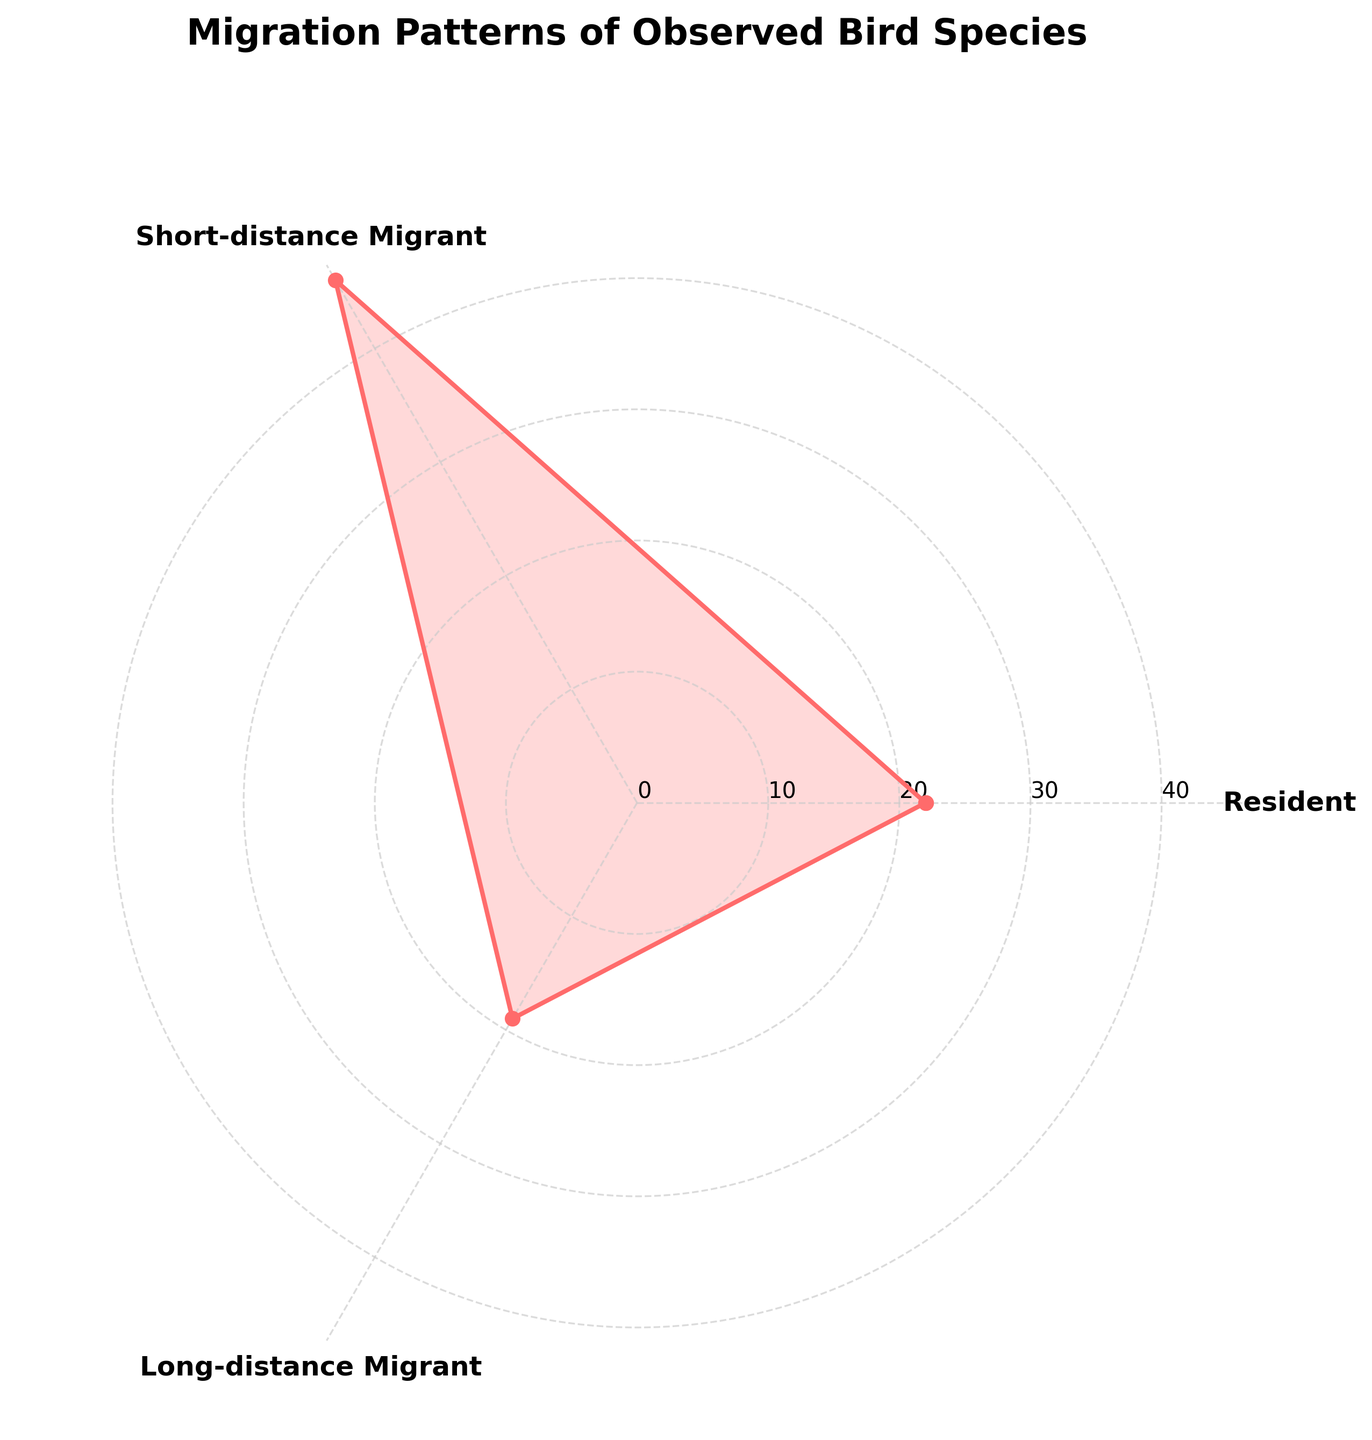What is the title of the rose chart? The title of the chart is typically displayed at the top of the plot. It provides a brief description of the dataset being visualized.
Answer: Migration Patterns of Observed Bird Species How many groups are represented in the rose chart? The rose chart categorizes the migration patterns into different groups. These groups are usually marked by labels around the chart.
Answer: 3 groups Which category has the highest value? To find the category with the highest value, look at the lengths of the segments extending from the center to the outer edge. The segment that extends the farthest represents the highest value.
Answer: Short-distance Migrant What is the approximate value for the Long-distance Migrant category? Look at the segment labeled "Long-distance Migrant" and estimate its value by comparing it to the radial labels.
Answer: Approximately 19 Compare the values for Resident and Short-distance Migrant categories. Which one is higher? To compare, visually check the lengths of the segments for both categories. The longer segment indicates a higher value.
Answer: Short-distance Migrant Is there any category with a value of 0? Check each segment for any category that does not extend from the center. If one category has no segment, it means its value is zero.
Answer: No What is the total value of all categories combined? Add the values of all the segments for the categories displayed on the rose chart. Sum up Resident (22), Short-distance Migrant (46), and Long-distance Migrant (19).
Answer: 87 Which group is closest in value to the Long-distance Migrant? Visually inspect the values of each category, and find the one closest in length to the Long-distance Migrant segment.
Answer: Resident How does the Resident category compare to the average value of all categories? First, calculate the average value of all categories ([22 + 46 + 19]/3 = 29). Then compare the value of the Resident category to this average.
Answer: Lower What is the difference between the highest and the lowest category values? Identify the highest and lowest values among the segments and subtract the lowest from the highest. The highest (Short-distance Migrant: 46) minus the lowest (Long-distance Migrant: 19).
Answer: 27 